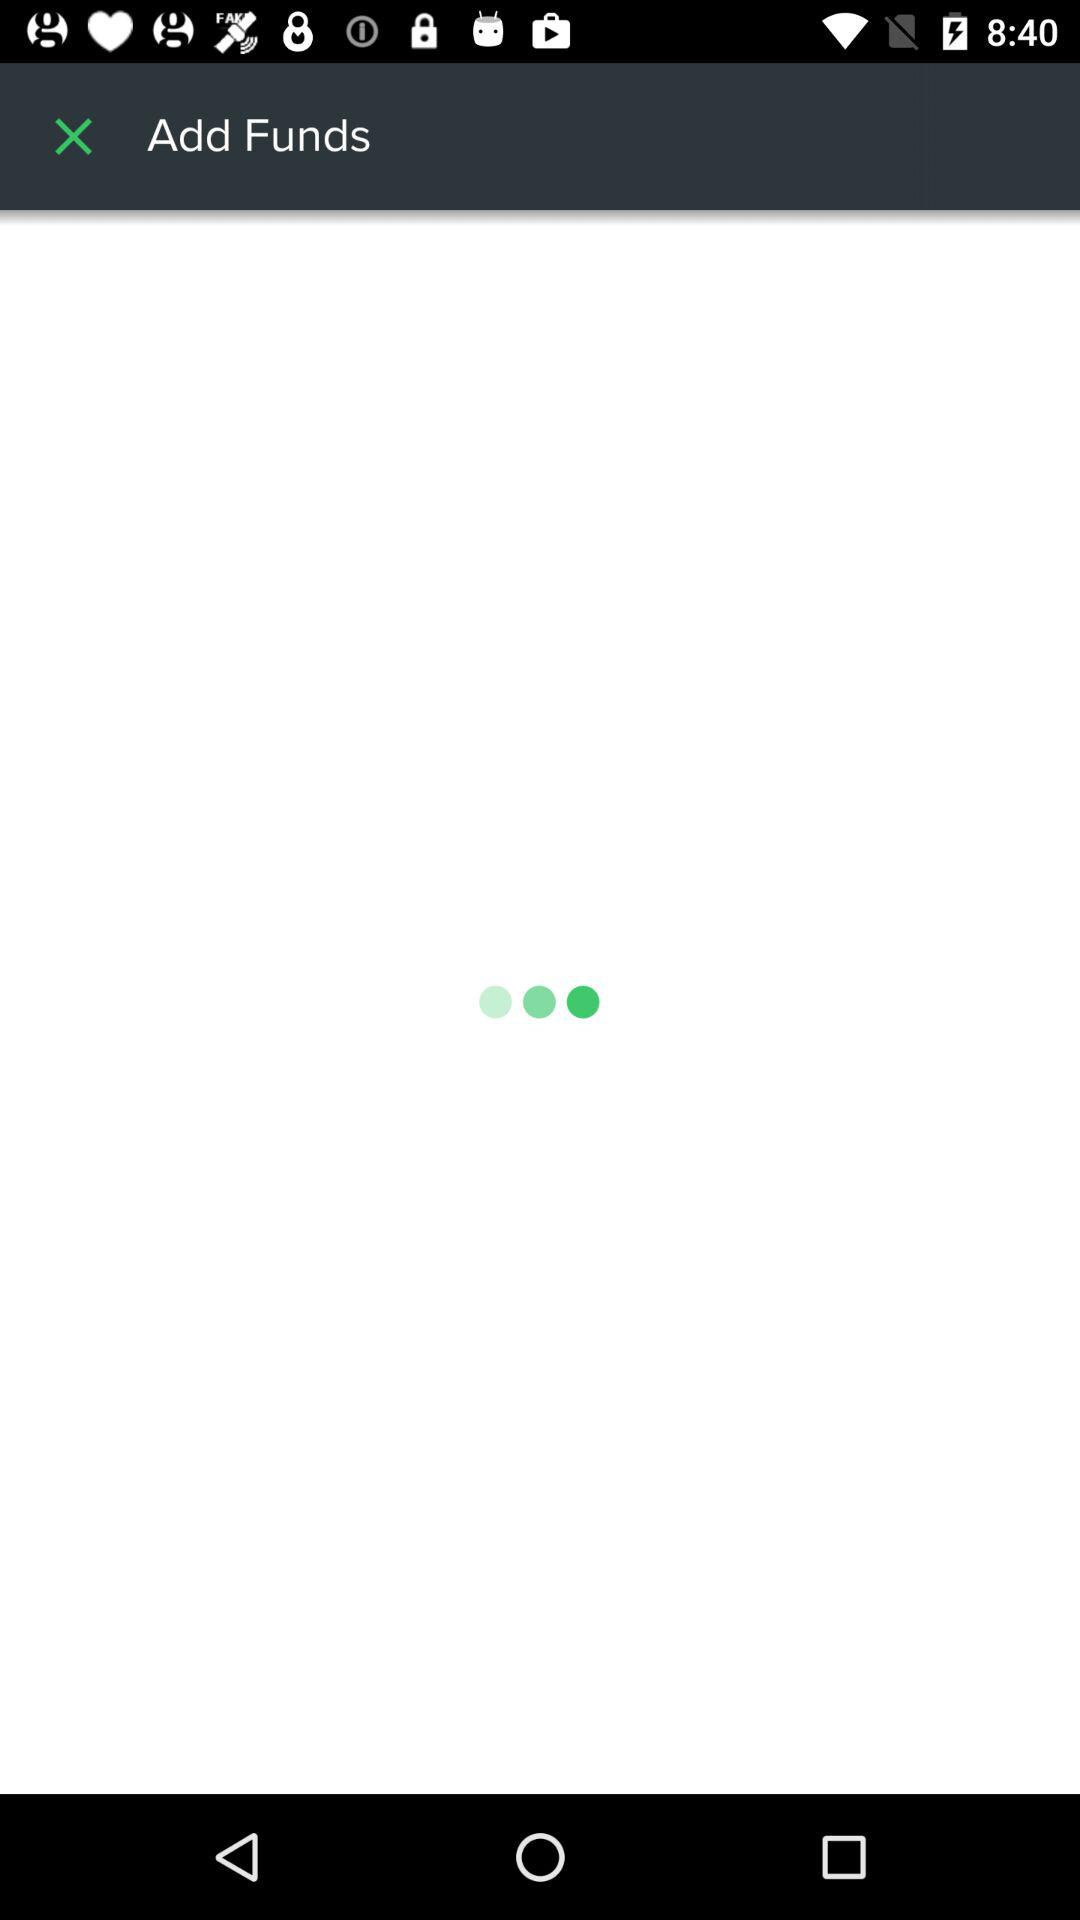What is the email address given? The given email address is "appcrawler2@gmail.com". 